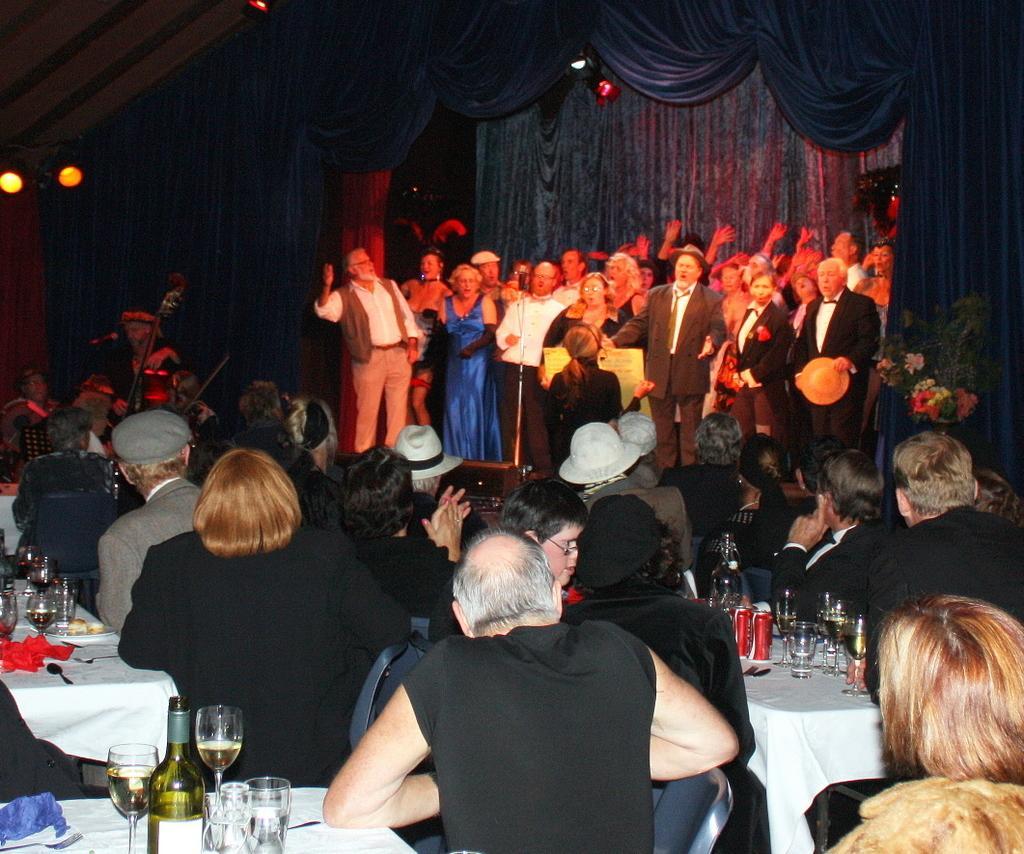Can you describe this image briefly? In this picture there is a group of men and women performing a music on the stage. In the front there is a group of persons sitting on the dining table as audience and enjoy the music. Behind there is a blue curtain and spotlight. 